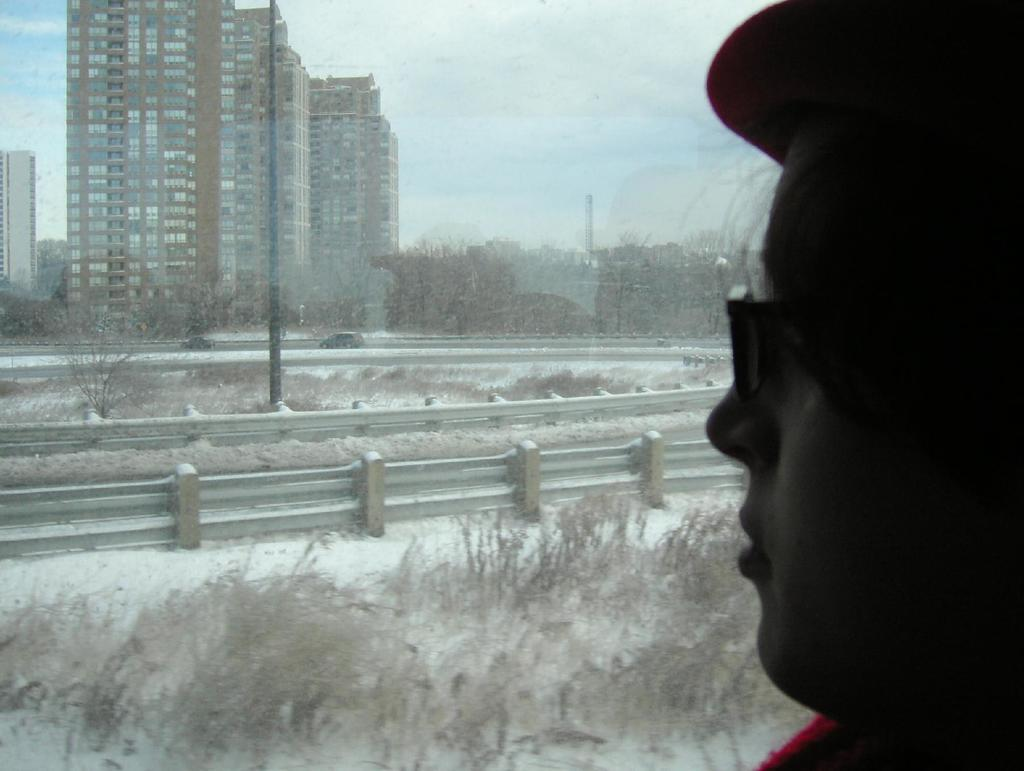What is the person in the image wearing on their head? The person in the image is wearing a cap. What else can be seen on the person's face? The person is also wearing spectacles. What type of barrier can be seen in the image? There is a fence in the image. What is visible on the road in the image? Vehicles are visible on the road in the image. What type of vegetation is present in the image? There are trees in the image. What type of structures are visible in the image? There are buildings in the image. What can be seen in the background of the image? The sky with clouds is visible in the background of the image. What type of distribution system is visible in the image? There is no distribution system present in the image. How does the wind affect the person in the image? The image does not provide any information about the wind, so it cannot be determined how it affects the person. 